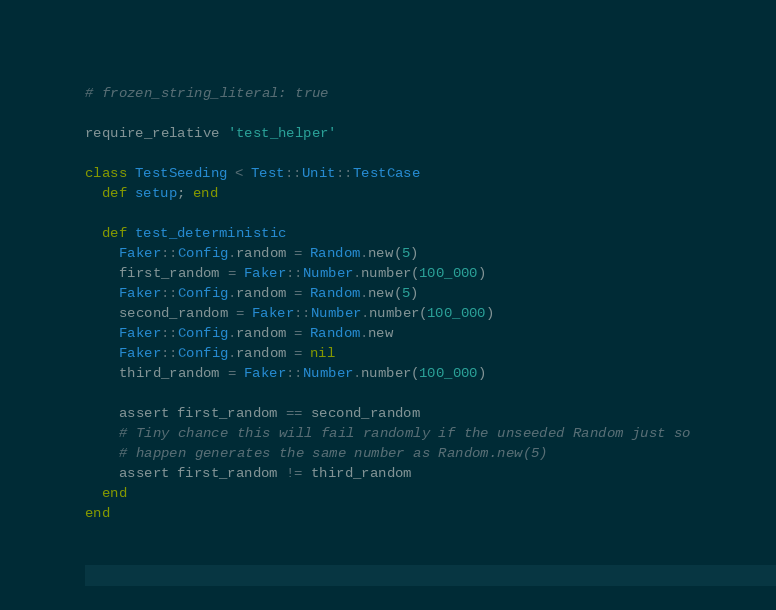Convert code to text. <code><loc_0><loc_0><loc_500><loc_500><_Ruby_># frozen_string_literal: true

require_relative 'test_helper'

class TestSeeding < Test::Unit::TestCase
  def setup; end

  def test_deterministic
    Faker::Config.random = Random.new(5)
    first_random = Faker::Number.number(100_000)
    Faker::Config.random = Random.new(5)
    second_random = Faker::Number.number(100_000)
    Faker::Config.random = Random.new
    Faker::Config.random = nil
    third_random = Faker::Number.number(100_000)

    assert first_random == second_random
    # Tiny chance this will fail randomly if the unseeded Random just so
    # happen generates the same number as Random.new(5)
    assert first_random != third_random
  end
end
</code> 